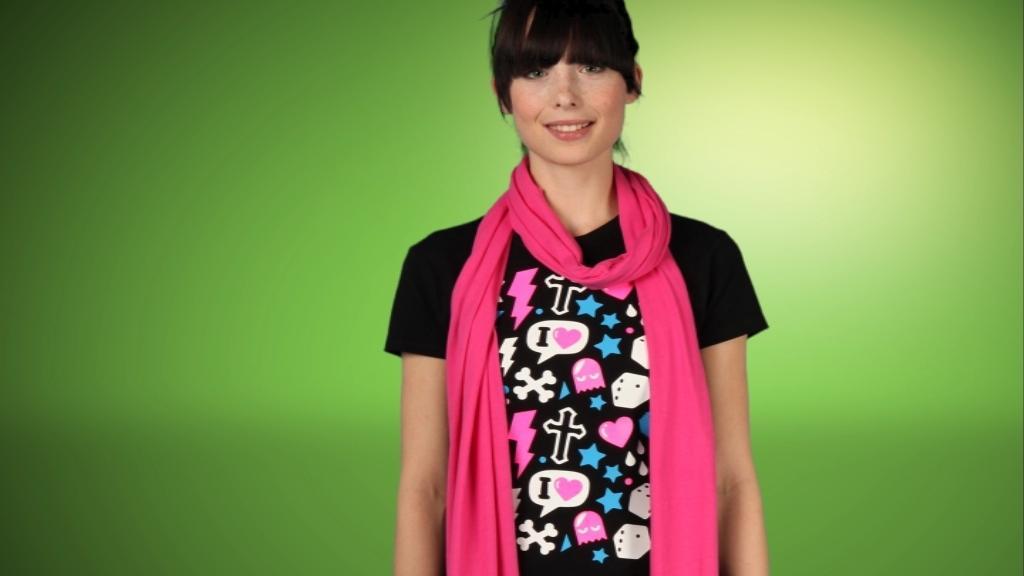Please provide a concise description of this image. In this picture we can see a woman is standing and smiling, she wore a pink color scarf. we can see a green color background. 